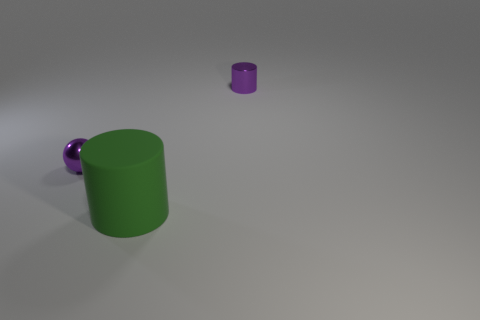Add 3 brown matte blocks. How many objects exist? 6 Subtract all cylinders. How many objects are left? 1 Subtract 0 red cubes. How many objects are left? 3 Subtract all balls. Subtract all cylinders. How many objects are left? 0 Add 1 large things. How many large things are left? 2 Add 3 green rubber cylinders. How many green rubber cylinders exist? 4 